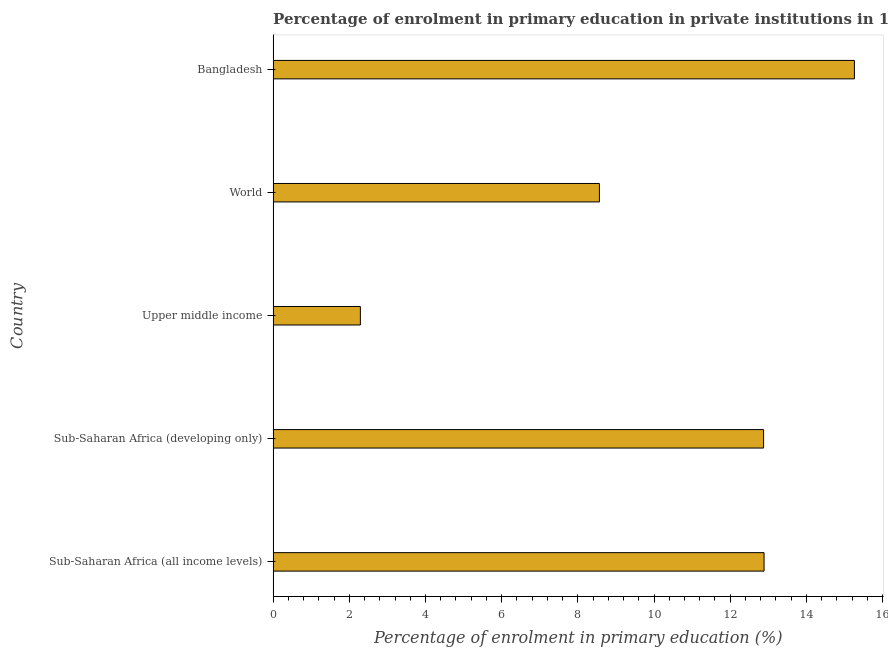What is the title of the graph?
Provide a succinct answer. Percentage of enrolment in primary education in private institutions in 1978. What is the label or title of the X-axis?
Your answer should be compact. Percentage of enrolment in primary education (%). What is the enrolment percentage in primary education in Sub-Saharan Africa (all income levels)?
Ensure brevity in your answer.  12.89. Across all countries, what is the maximum enrolment percentage in primary education?
Ensure brevity in your answer.  15.26. Across all countries, what is the minimum enrolment percentage in primary education?
Your answer should be very brief. 2.29. In which country was the enrolment percentage in primary education minimum?
Offer a very short reply. Upper middle income. What is the sum of the enrolment percentage in primary education?
Keep it short and to the point. 51.88. What is the difference between the enrolment percentage in primary education in Bangladesh and Sub-Saharan Africa (all income levels)?
Keep it short and to the point. 2.37. What is the average enrolment percentage in primary education per country?
Offer a terse response. 10.38. What is the median enrolment percentage in primary education?
Provide a short and direct response. 12.88. What is the ratio of the enrolment percentage in primary education in Bangladesh to that in World?
Your response must be concise. 1.78. What is the difference between the highest and the second highest enrolment percentage in primary education?
Ensure brevity in your answer.  2.37. What is the difference between the highest and the lowest enrolment percentage in primary education?
Make the answer very short. 12.97. In how many countries, is the enrolment percentage in primary education greater than the average enrolment percentage in primary education taken over all countries?
Your answer should be compact. 3. Are all the bars in the graph horizontal?
Offer a very short reply. Yes. How many countries are there in the graph?
Offer a very short reply. 5. What is the difference between two consecutive major ticks on the X-axis?
Your answer should be compact. 2. Are the values on the major ticks of X-axis written in scientific E-notation?
Offer a terse response. No. What is the Percentage of enrolment in primary education (%) of Sub-Saharan Africa (all income levels)?
Provide a succinct answer. 12.89. What is the Percentage of enrolment in primary education (%) in Sub-Saharan Africa (developing only)?
Keep it short and to the point. 12.88. What is the Percentage of enrolment in primary education (%) of Upper middle income?
Your answer should be very brief. 2.29. What is the Percentage of enrolment in primary education (%) in World?
Keep it short and to the point. 8.57. What is the Percentage of enrolment in primary education (%) of Bangladesh?
Provide a succinct answer. 15.26. What is the difference between the Percentage of enrolment in primary education (%) in Sub-Saharan Africa (all income levels) and Sub-Saharan Africa (developing only)?
Make the answer very short. 0.01. What is the difference between the Percentage of enrolment in primary education (%) in Sub-Saharan Africa (all income levels) and Upper middle income?
Ensure brevity in your answer.  10.6. What is the difference between the Percentage of enrolment in primary education (%) in Sub-Saharan Africa (all income levels) and World?
Ensure brevity in your answer.  4.32. What is the difference between the Percentage of enrolment in primary education (%) in Sub-Saharan Africa (all income levels) and Bangladesh?
Your answer should be very brief. -2.37. What is the difference between the Percentage of enrolment in primary education (%) in Sub-Saharan Africa (developing only) and Upper middle income?
Give a very brief answer. 10.59. What is the difference between the Percentage of enrolment in primary education (%) in Sub-Saharan Africa (developing only) and World?
Make the answer very short. 4.31. What is the difference between the Percentage of enrolment in primary education (%) in Sub-Saharan Africa (developing only) and Bangladesh?
Keep it short and to the point. -2.38. What is the difference between the Percentage of enrolment in primary education (%) in Upper middle income and World?
Your answer should be very brief. -6.27. What is the difference between the Percentage of enrolment in primary education (%) in Upper middle income and Bangladesh?
Your response must be concise. -12.97. What is the difference between the Percentage of enrolment in primary education (%) in World and Bangladesh?
Your response must be concise. -6.7. What is the ratio of the Percentage of enrolment in primary education (%) in Sub-Saharan Africa (all income levels) to that in Sub-Saharan Africa (developing only)?
Provide a succinct answer. 1. What is the ratio of the Percentage of enrolment in primary education (%) in Sub-Saharan Africa (all income levels) to that in Upper middle income?
Ensure brevity in your answer.  5.63. What is the ratio of the Percentage of enrolment in primary education (%) in Sub-Saharan Africa (all income levels) to that in World?
Your answer should be compact. 1.5. What is the ratio of the Percentage of enrolment in primary education (%) in Sub-Saharan Africa (all income levels) to that in Bangladesh?
Keep it short and to the point. 0.84. What is the ratio of the Percentage of enrolment in primary education (%) in Sub-Saharan Africa (developing only) to that in Upper middle income?
Your answer should be very brief. 5.62. What is the ratio of the Percentage of enrolment in primary education (%) in Sub-Saharan Africa (developing only) to that in World?
Provide a short and direct response. 1.5. What is the ratio of the Percentage of enrolment in primary education (%) in Sub-Saharan Africa (developing only) to that in Bangladesh?
Your answer should be very brief. 0.84. What is the ratio of the Percentage of enrolment in primary education (%) in Upper middle income to that in World?
Offer a very short reply. 0.27. What is the ratio of the Percentage of enrolment in primary education (%) in World to that in Bangladesh?
Offer a terse response. 0.56. 